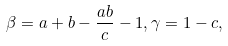<formula> <loc_0><loc_0><loc_500><loc_500>\beta = a + b - \frac { a b } { c } - 1 , \gamma = 1 - c ,</formula> 